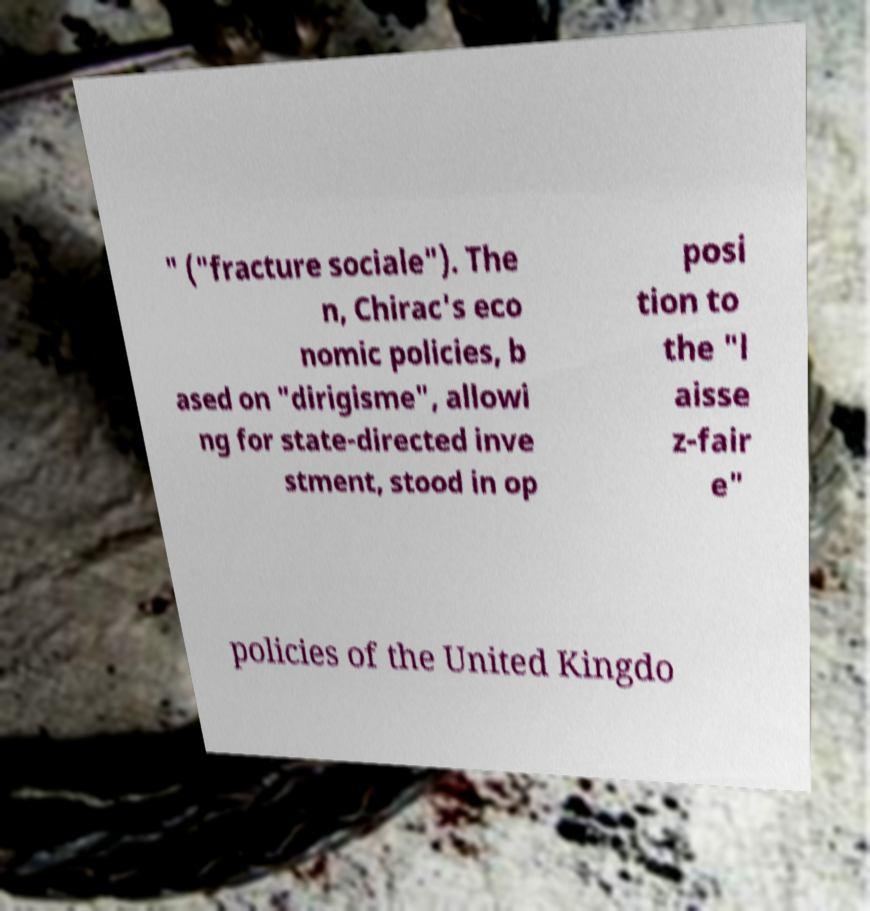Please read and relay the text visible in this image. What does it say? " ("fracture sociale"). The n, Chirac's eco nomic policies, b ased on "dirigisme", allowi ng for state-directed inve stment, stood in op posi tion to the "l aisse z-fair e" policies of the United Kingdo 